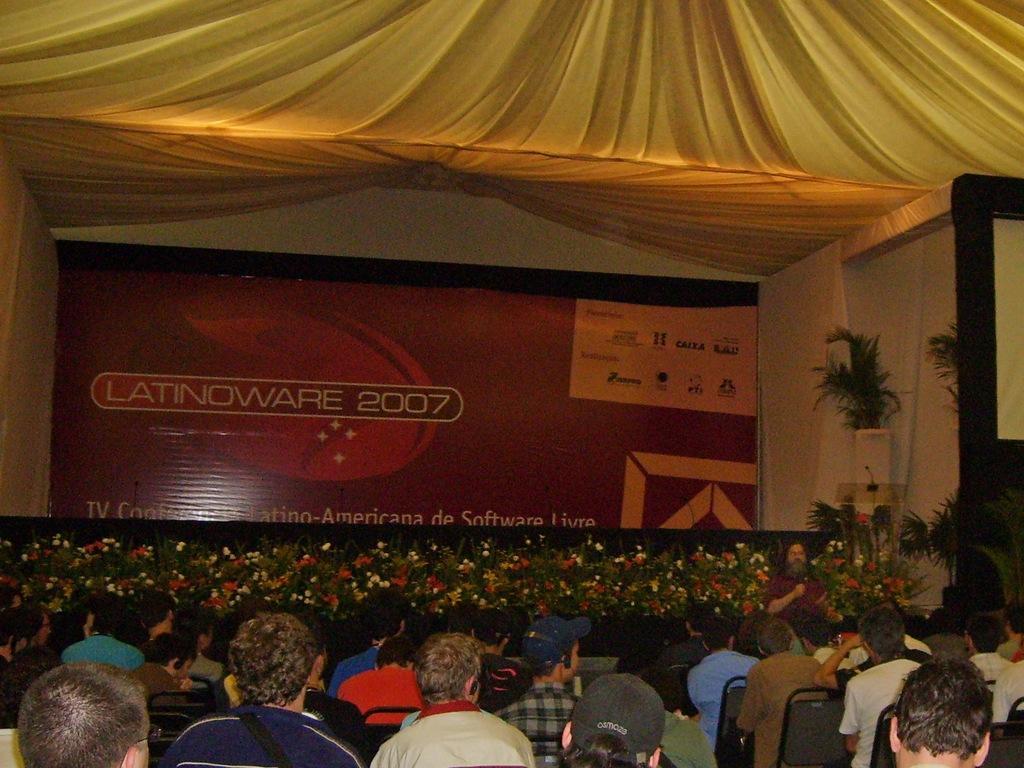Please provide a concise description of this image. In this image there are group of persons sitting. In the background there is a banner with some text written on it. On the top there is a tent which is yellow in colour. On the right side there are plants and there is a board which is black and yellow in colour. 